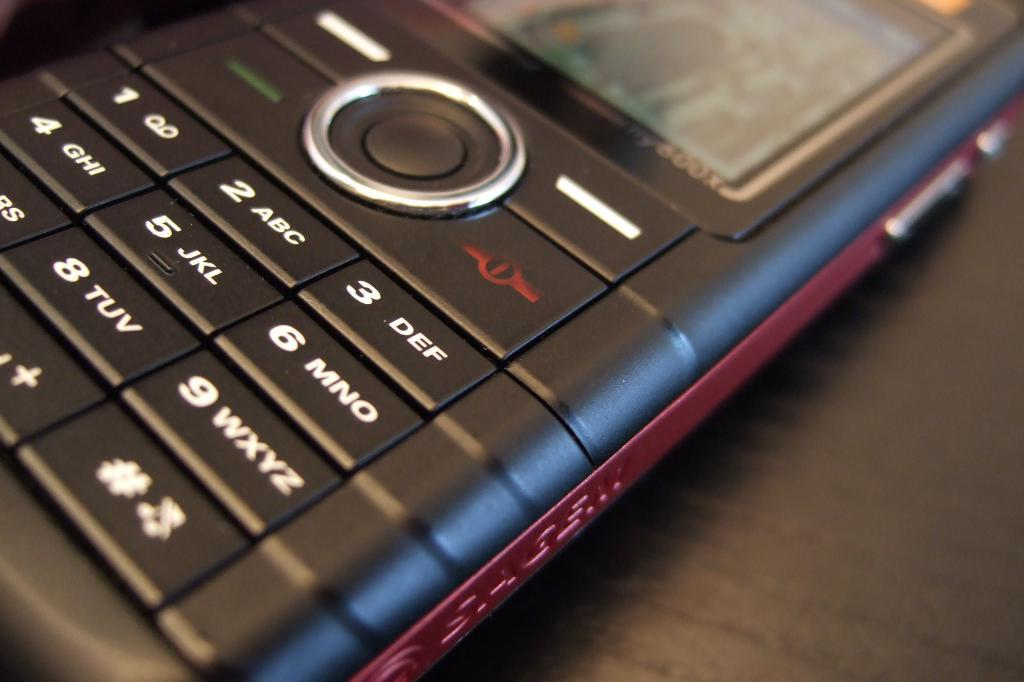<image>
Provide a brief description of the given image. a close up of a cell phone keyboard with keys like 2 ABC 